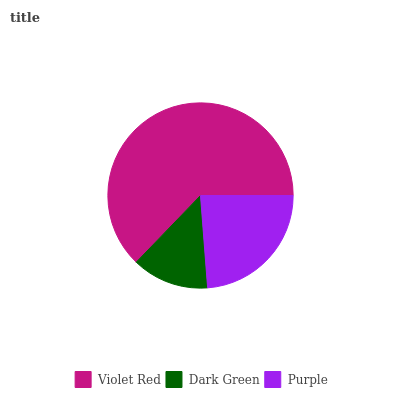Is Dark Green the minimum?
Answer yes or no. Yes. Is Violet Red the maximum?
Answer yes or no. Yes. Is Purple the minimum?
Answer yes or no. No. Is Purple the maximum?
Answer yes or no. No. Is Purple greater than Dark Green?
Answer yes or no. Yes. Is Dark Green less than Purple?
Answer yes or no. Yes. Is Dark Green greater than Purple?
Answer yes or no. No. Is Purple less than Dark Green?
Answer yes or no. No. Is Purple the high median?
Answer yes or no. Yes. Is Purple the low median?
Answer yes or no. Yes. Is Dark Green the high median?
Answer yes or no. No. Is Dark Green the low median?
Answer yes or no. No. 